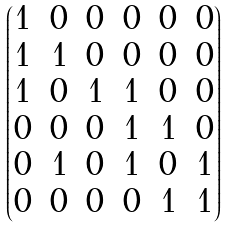Convert formula to latex. <formula><loc_0><loc_0><loc_500><loc_500>\begin{pmatrix} 1 & 0 & 0 & 0 & 0 & 0 \\ 1 & 1 & 0 & 0 & 0 & 0 \\ 1 & 0 & 1 & 1 & 0 & 0 \\ 0 & 0 & 0 & 1 & 1 & 0 \\ 0 & 1 & 0 & 1 & 0 & 1 \\ 0 & 0 & 0 & 0 & 1 & 1 \end{pmatrix}</formula> 